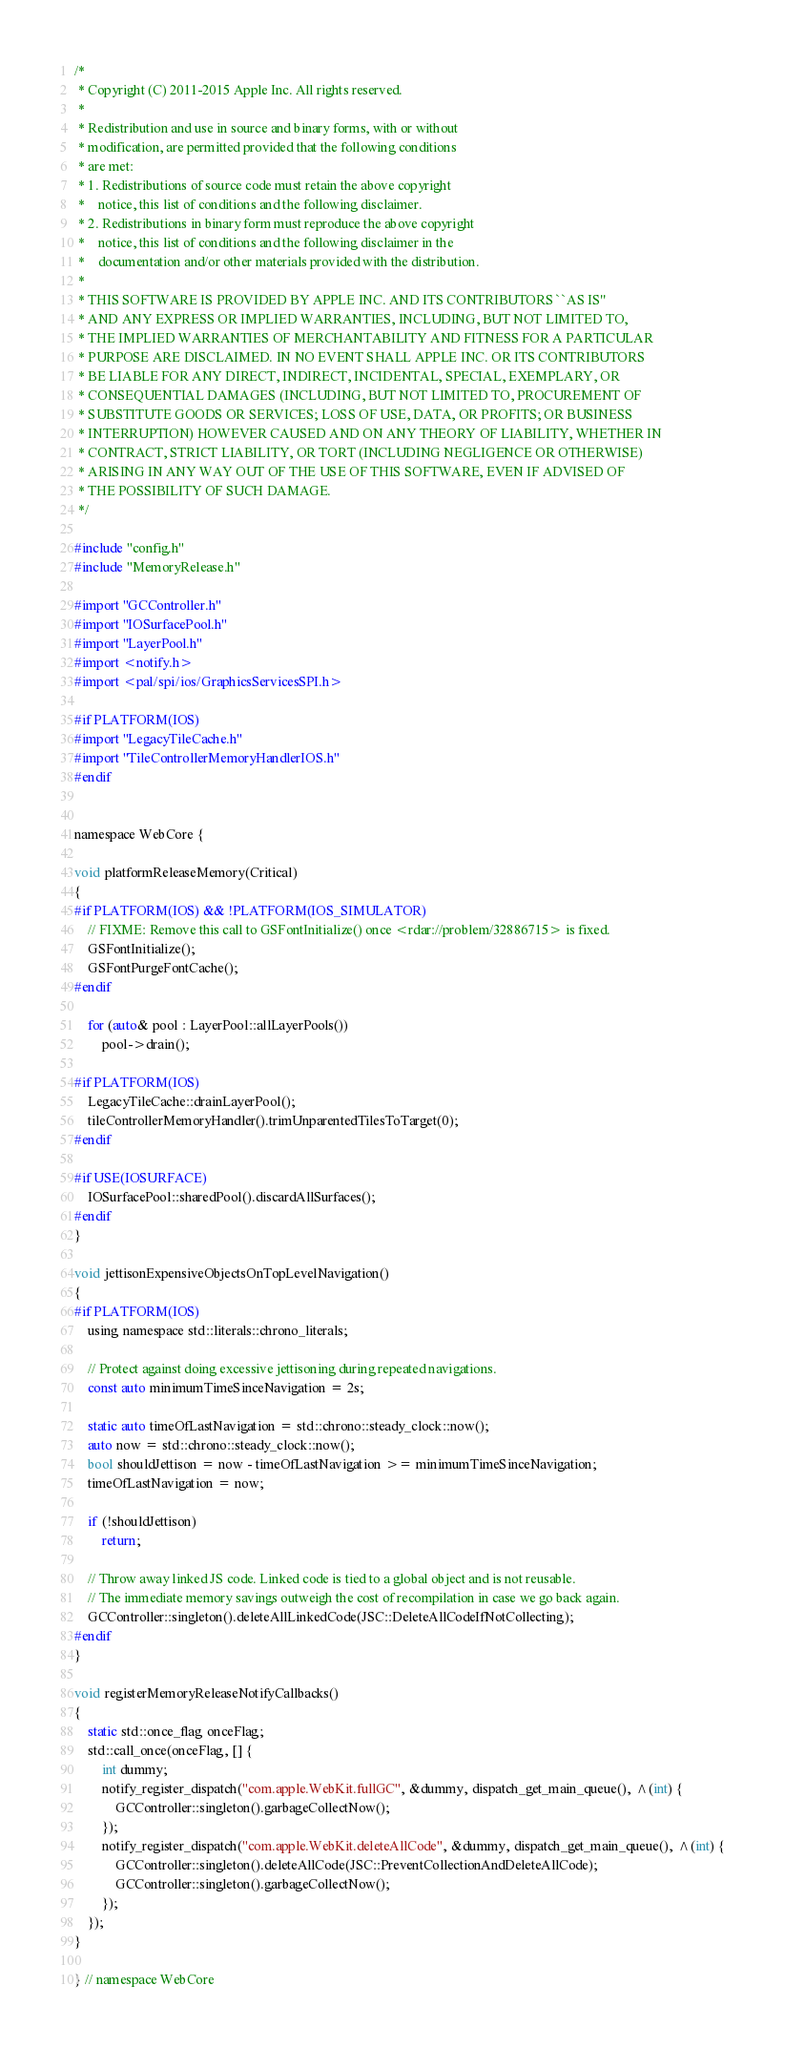Convert code to text. <code><loc_0><loc_0><loc_500><loc_500><_ObjectiveC_>/*
 * Copyright (C) 2011-2015 Apple Inc. All rights reserved.
 *
 * Redistribution and use in source and binary forms, with or without
 * modification, are permitted provided that the following conditions
 * are met:
 * 1. Redistributions of source code must retain the above copyright
 *    notice, this list of conditions and the following disclaimer.
 * 2. Redistributions in binary form must reproduce the above copyright
 *    notice, this list of conditions and the following disclaimer in the
 *    documentation and/or other materials provided with the distribution.
 *
 * THIS SOFTWARE IS PROVIDED BY APPLE INC. AND ITS CONTRIBUTORS ``AS IS''
 * AND ANY EXPRESS OR IMPLIED WARRANTIES, INCLUDING, BUT NOT LIMITED TO,
 * THE IMPLIED WARRANTIES OF MERCHANTABILITY AND FITNESS FOR A PARTICULAR
 * PURPOSE ARE DISCLAIMED. IN NO EVENT SHALL APPLE INC. OR ITS CONTRIBUTORS
 * BE LIABLE FOR ANY DIRECT, INDIRECT, INCIDENTAL, SPECIAL, EXEMPLARY, OR
 * CONSEQUENTIAL DAMAGES (INCLUDING, BUT NOT LIMITED TO, PROCUREMENT OF
 * SUBSTITUTE GOODS OR SERVICES; LOSS OF USE, DATA, OR PROFITS; OR BUSINESS
 * INTERRUPTION) HOWEVER CAUSED AND ON ANY THEORY OF LIABILITY, WHETHER IN
 * CONTRACT, STRICT LIABILITY, OR TORT (INCLUDING NEGLIGENCE OR OTHERWISE)
 * ARISING IN ANY WAY OUT OF THE USE OF THIS SOFTWARE, EVEN IF ADVISED OF
 * THE POSSIBILITY OF SUCH DAMAGE.
 */

#include "config.h"
#include "MemoryRelease.h"

#import "GCController.h"
#import "IOSurfacePool.h"
#import "LayerPool.h"
#import <notify.h>
#import <pal/spi/ios/GraphicsServicesSPI.h>

#if PLATFORM(IOS)
#import "LegacyTileCache.h"
#import "TileControllerMemoryHandlerIOS.h"
#endif


namespace WebCore {

void platformReleaseMemory(Critical)
{
#if PLATFORM(IOS) && !PLATFORM(IOS_SIMULATOR)
    // FIXME: Remove this call to GSFontInitialize() once <rdar://problem/32886715> is fixed.
    GSFontInitialize();
    GSFontPurgeFontCache();
#endif

    for (auto& pool : LayerPool::allLayerPools())
        pool->drain();

#if PLATFORM(IOS)
    LegacyTileCache::drainLayerPool();
    tileControllerMemoryHandler().trimUnparentedTilesToTarget(0);
#endif

#if USE(IOSURFACE)
    IOSurfacePool::sharedPool().discardAllSurfaces();
#endif
}

void jettisonExpensiveObjectsOnTopLevelNavigation()
{
#if PLATFORM(IOS)
    using namespace std::literals::chrono_literals;

    // Protect against doing excessive jettisoning during repeated navigations.
    const auto minimumTimeSinceNavigation = 2s;

    static auto timeOfLastNavigation = std::chrono::steady_clock::now();
    auto now = std::chrono::steady_clock::now();
    bool shouldJettison = now - timeOfLastNavigation >= minimumTimeSinceNavigation;
    timeOfLastNavigation = now;

    if (!shouldJettison)
        return;

    // Throw away linked JS code. Linked code is tied to a global object and is not reusable.
    // The immediate memory savings outweigh the cost of recompilation in case we go back again.
    GCController::singleton().deleteAllLinkedCode(JSC::DeleteAllCodeIfNotCollecting);
#endif
}

void registerMemoryReleaseNotifyCallbacks()
{
    static std::once_flag onceFlag;
    std::call_once(onceFlag, [] {
        int dummy;
        notify_register_dispatch("com.apple.WebKit.fullGC", &dummy, dispatch_get_main_queue(), ^(int) {
            GCController::singleton().garbageCollectNow();
        });
        notify_register_dispatch("com.apple.WebKit.deleteAllCode", &dummy, dispatch_get_main_queue(), ^(int) {
            GCController::singleton().deleteAllCode(JSC::PreventCollectionAndDeleteAllCode);
            GCController::singleton().garbageCollectNow();
        });
    });
}

} // namespace WebCore
</code> 